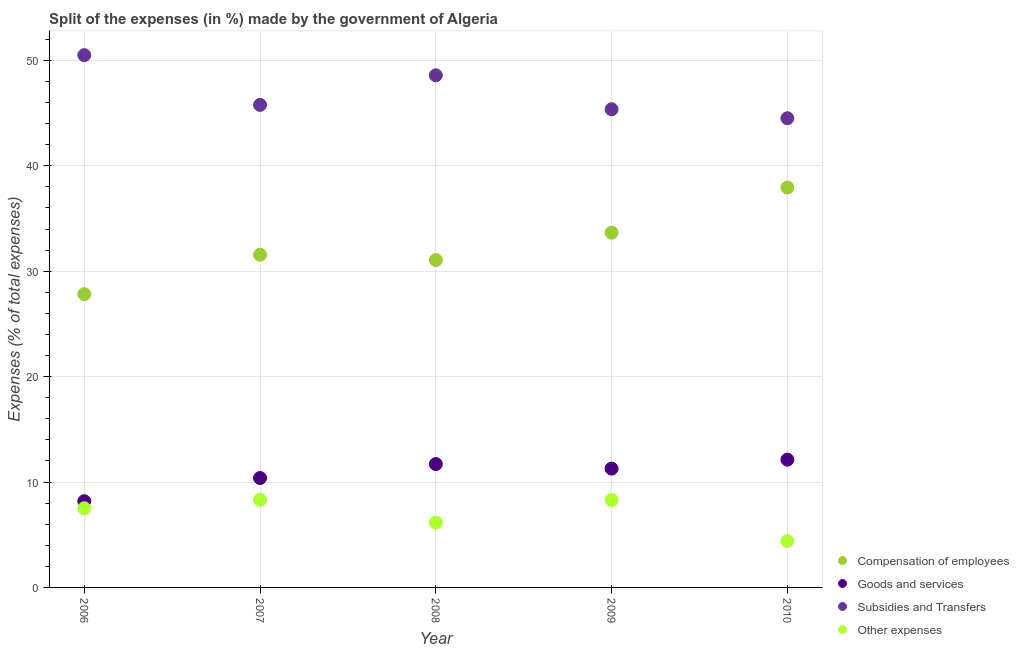How many different coloured dotlines are there?
Your answer should be very brief. 4. Is the number of dotlines equal to the number of legend labels?
Your answer should be compact. Yes. What is the percentage of amount spent on compensation of employees in 2010?
Your response must be concise. 37.94. Across all years, what is the maximum percentage of amount spent on goods and services?
Provide a succinct answer. 12.12. Across all years, what is the minimum percentage of amount spent on compensation of employees?
Offer a very short reply. 27.83. What is the total percentage of amount spent on subsidies in the graph?
Keep it short and to the point. 234.76. What is the difference between the percentage of amount spent on goods and services in 2007 and that in 2009?
Make the answer very short. -0.89. What is the difference between the percentage of amount spent on other expenses in 2007 and the percentage of amount spent on subsidies in 2010?
Provide a succinct answer. -36.2. What is the average percentage of amount spent on compensation of employees per year?
Your answer should be very brief. 32.41. In the year 2006, what is the difference between the percentage of amount spent on other expenses and percentage of amount spent on compensation of employees?
Your answer should be very brief. -20.32. In how many years, is the percentage of amount spent on other expenses greater than 16 %?
Give a very brief answer. 0. What is the ratio of the percentage of amount spent on subsidies in 2007 to that in 2008?
Offer a terse response. 0.94. Is the percentage of amount spent on compensation of employees in 2006 less than that in 2007?
Your answer should be very brief. Yes. Is the difference between the percentage of amount spent on other expenses in 2008 and 2009 greater than the difference between the percentage of amount spent on subsidies in 2008 and 2009?
Provide a succinct answer. No. What is the difference between the highest and the second highest percentage of amount spent on subsidies?
Ensure brevity in your answer.  1.91. What is the difference between the highest and the lowest percentage of amount spent on other expenses?
Offer a very short reply. 3.92. In how many years, is the percentage of amount spent on goods and services greater than the average percentage of amount spent on goods and services taken over all years?
Make the answer very short. 3. Is it the case that in every year, the sum of the percentage of amount spent on compensation of employees and percentage of amount spent on goods and services is greater than the percentage of amount spent on subsidies?
Offer a terse response. No. Does the percentage of amount spent on subsidies monotonically increase over the years?
Make the answer very short. No. Is the percentage of amount spent on other expenses strictly greater than the percentage of amount spent on compensation of employees over the years?
Provide a succinct answer. No. Is the percentage of amount spent on subsidies strictly less than the percentage of amount spent on goods and services over the years?
Provide a succinct answer. No. How many dotlines are there?
Make the answer very short. 4. How many years are there in the graph?
Your answer should be very brief. 5. What is the difference between two consecutive major ticks on the Y-axis?
Provide a succinct answer. 10. Are the values on the major ticks of Y-axis written in scientific E-notation?
Ensure brevity in your answer.  No. Does the graph contain any zero values?
Provide a succinct answer. No. Where does the legend appear in the graph?
Offer a terse response. Bottom right. How many legend labels are there?
Your answer should be very brief. 4. What is the title of the graph?
Give a very brief answer. Split of the expenses (in %) made by the government of Algeria. What is the label or title of the Y-axis?
Your answer should be compact. Expenses (% of total expenses). What is the Expenses (% of total expenses) of Compensation of employees in 2006?
Offer a terse response. 27.83. What is the Expenses (% of total expenses) of Goods and services in 2006?
Offer a terse response. 8.18. What is the Expenses (% of total expenses) of Subsidies and Transfers in 2006?
Give a very brief answer. 50.5. What is the Expenses (% of total expenses) of Other expenses in 2006?
Your answer should be very brief. 7.51. What is the Expenses (% of total expenses) of Compensation of employees in 2007?
Provide a succinct answer. 31.57. What is the Expenses (% of total expenses) in Goods and services in 2007?
Your answer should be compact. 10.38. What is the Expenses (% of total expenses) in Subsidies and Transfers in 2007?
Ensure brevity in your answer.  45.78. What is the Expenses (% of total expenses) of Other expenses in 2007?
Offer a terse response. 8.32. What is the Expenses (% of total expenses) of Compensation of employees in 2008?
Make the answer very short. 31.07. What is the Expenses (% of total expenses) in Goods and services in 2008?
Offer a very short reply. 11.7. What is the Expenses (% of total expenses) in Subsidies and Transfers in 2008?
Your response must be concise. 48.59. What is the Expenses (% of total expenses) in Other expenses in 2008?
Make the answer very short. 6.15. What is the Expenses (% of total expenses) in Compensation of employees in 2009?
Give a very brief answer. 33.66. What is the Expenses (% of total expenses) of Goods and services in 2009?
Provide a short and direct response. 11.27. What is the Expenses (% of total expenses) in Subsidies and Transfers in 2009?
Your answer should be very brief. 45.37. What is the Expenses (% of total expenses) of Other expenses in 2009?
Offer a very short reply. 8.3. What is the Expenses (% of total expenses) of Compensation of employees in 2010?
Your answer should be compact. 37.94. What is the Expenses (% of total expenses) in Goods and services in 2010?
Your answer should be compact. 12.12. What is the Expenses (% of total expenses) of Subsidies and Transfers in 2010?
Offer a terse response. 44.52. What is the Expenses (% of total expenses) of Other expenses in 2010?
Give a very brief answer. 4.39. Across all years, what is the maximum Expenses (% of total expenses) in Compensation of employees?
Your answer should be very brief. 37.94. Across all years, what is the maximum Expenses (% of total expenses) in Goods and services?
Your answer should be very brief. 12.12. Across all years, what is the maximum Expenses (% of total expenses) in Subsidies and Transfers?
Provide a short and direct response. 50.5. Across all years, what is the maximum Expenses (% of total expenses) of Other expenses?
Provide a succinct answer. 8.32. Across all years, what is the minimum Expenses (% of total expenses) in Compensation of employees?
Give a very brief answer. 27.83. Across all years, what is the minimum Expenses (% of total expenses) in Goods and services?
Make the answer very short. 8.18. Across all years, what is the minimum Expenses (% of total expenses) of Subsidies and Transfers?
Your answer should be compact. 44.52. Across all years, what is the minimum Expenses (% of total expenses) of Other expenses?
Keep it short and to the point. 4.39. What is the total Expenses (% of total expenses) in Compensation of employees in the graph?
Make the answer very short. 162.06. What is the total Expenses (% of total expenses) of Goods and services in the graph?
Your answer should be very brief. 53.66. What is the total Expenses (% of total expenses) of Subsidies and Transfers in the graph?
Offer a terse response. 234.76. What is the total Expenses (% of total expenses) in Other expenses in the graph?
Offer a terse response. 34.67. What is the difference between the Expenses (% of total expenses) in Compensation of employees in 2006 and that in 2007?
Your answer should be very brief. -3.74. What is the difference between the Expenses (% of total expenses) of Goods and services in 2006 and that in 2007?
Your response must be concise. -2.2. What is the difference between the Expenses (% of total expenses) of Subsidies and Transfers in 2006 and that in 2007?
Ensure brevity in your answer.  4.72. What is the difference between the Expenses (% of total expenses) in Other expenses in 2006 and that in 2007?
Ensure brevity in your answer.  -0.8. What is the difference between the Expenses (% of total expenses) in Compensation of employees in 2006 and that in 2008?
Make the answer very short. -3.24. What is the difference between the Expenses (% of total expenses) in Goods and services in 2006 and that in 2008?
Make the answer very short. -3.52. What is the difference between the Expenses (% of total expenses) of Subsidies and Transfers in 2006 and that in 2008?
Provide a succinct answer. 1.91. What is the difference between the Expenses (% of total expenses) in Other expenses in 2006 and that in 2008?
Give a very brief answer. 1.36. What is the difference between the Expenses (% of total expenses) of Compensation of employees in 2006 and that in 2009?
Provide a short and direct response. -5.83. What is the difference between the Expenses (% of total expenses) of Goods and services in 2006 and that in 2009?
Offer a very short reply. -3.09. What is the difference between the Expenses (% of total expenses) of Subsidies and Transfers in 2006 and that in 2009?
Offer a very short reply. 5.14. What is the difference between the Expenses (% of total expenses) of Other expenses in 2006 and that in 2009?
Your answer should be very brief. -0.79. What is the difference between the Expenses (% of total expenses) of Compensation of employees in 2006 and that in 2010?
Your response must be concise. -10.11. What is the difference between the Expenses (% of total expenses) of Goods and services in 2006 and that in 2010?
Your response must be concise. -3.94. What is the difference between the Expenses (% of total expenses) of Subsidies and Transfers in 2006 and that in 2010?
Provide a succinct answer. 5.99. What is the difference between the Expenses (% of total expenses) of Other expenses in 2006 and that in 2010?
Give a very brief answer. 3.12. What is the difference between the Expenses (% of total expenses) of Compensation of employees in 2007 and that in 2008?
Ensure brevity in your answer.  0.5. What is the difference between the Expenses (% of total expenses) in Goods and services in 2007 and that in 2008?
Ensure brevity in your answer.  -1.32. What is the difference between the Expenses (% of total expenses) in Subsidies and Transfers in 2007 and that in 2008?
Your response must be concise. -2.81. What is the difference between the Expenses (% of total expenses) of Other expenses in 2007 and that in 2008?
Your answer should be compact. 2.17. What is the difference between the Expenses (% of total expenses) of Compensation of employees in 2007 and that in 2009?
Ensure brevity in your answer.  -2.09. What is the difference between the Expenses (% of total expenses) of Goods and services in 2007 and that in 2009?
Ensure brevity in your answer.  -0.89. What is the difference between the Expenses (% of total expenses) of Subsidies and Transfers in 2007 and that in 2009?
Offer a very short reply. 0.42. What is the difference between the Expenses (% of total expenses) of Other expenses in 2007 and that in 2009?
Provide a short and direct response. 0.02. What is the difference between the Expenses (% of total expenses) of Compensation of employees in 2007 and that in 2010?
Make the answer very short. -6.37. What is the difference between the Expenses (% of total expenses) in Goods and services in 2007 and that in 2010?
Your response must be concise. -1.74. What is the difference between the Expenses (% of total expenses) of Subsidies and Transfers in 2007 and that in 2010?
Offer a very short reply. 1.27. What is the difference between the Expenses (% of total expenses) of Other expenses in 2007 and that in 2010?
Offer a very short reply. 3.92. What is the difference between the Expenses (% of total expenses) of Compensation of employees in 2008 and that in 2009?
Provide a short and direct response. -2.59. What is the difference between the Expenses (% of total expenses) in Goods and services in 2008 and that in 2009?
Your answer should be very brief. 0.43. What is the difference between the Expenses (% of total expenses) of Subsidies and Transfers in 2008 and that in 2009?
Keep it short and to the point. 3.22. What is the difference between the Expenses (% of total expenses) in Other expenses in 2008 and that in 2009?
Give a very brief answer. -2.15. What is the difference between the Expenses (% of total expenses) in Compensation of employees in 2008 and that in 2010?
Your answer should be very brief. -6.87. What is the difference between the Expenses (% of total expenses) in Goods and services in 2008 and that in 2010?
Offer a very short reply. -0.42. What is the difference between the Expenses (% of total expenses) in Subsidies and Transfers in 2008 and that in 2010?
Provide a succinct answer. 4.07. What is the difference between the Expenses (% of total expenses) of Other expenses in 2008 and that in 2010?
Make the answer very short. 1.75. What is the difference between the Expenses (% of total expenses) of Compensation of employees in 2009 and that in 2010?
Your answer should be very brief. -4.28. What is the difference between the Expenses (% of total expenses) of Goods and services in 2009 and that in 2010?
Your response must be concise. -0.85. What is the difference between the Expenses (% of total expenses) of Subsidies and Transfers in 2009 and that in 2010?
Provide a short and direct response. 0.85. What is the difference between the Expenses (% of total expenses) of Other expenses in 2009 and that in 2010?
Give a very brief answer. 3.91. What is the difference between the Expenses (% of total expenses) of Compensation of employees in 2006 and the Expenses (% of total expenses) of Goods and services in 2007?
Offer a terse response. 17.45. What is the difference between the Expenses (% of total expenses) in Compensation of employees in 2006 and the Expenses (% of total expenses) in Subsidies and Transfers in 2007?
Offer a terse response. -17.95. What is the difference between the Expenses (% of total expenses) of Compensation of employees in 2006 and the Expenses (% of total expenses) of Other expenses in 2007?
Keep it short and to the point. 19.51. What is the difference between the Expenses (% of total expenses) in Goods and services in 2006 and the Expenses (% of total expenses) in Subsidies and Transfers in 2007?
Your response must be concise. -37.6. What is the difference between the Expenses (% of total expenses) in Goods and services in 2006 and the Expenses (% of total expenses) in Other expenses in 2007?
Your answer should be compact. -0.14. What is the difference between the Expenses (% of total expenses) in Subsidies and Transfers in 2006 and the Expenses (% of total expenses) in Other expenses in 2007?
Provide a succinct answer. 42.19. What is the difference between the Expenses (% of total expenses) of Compensation of employees in 2006 and the Expenses (% of total expenses) of Goods and services in 2008?
Give a very brief answer. 16.13. What is the difference between the Expenses (% of total expenses) in Compensation of employees in 2006 and the Expenses (% of total expenses) in Subsidies and Transfers in 2008?
Offer a very short reply. -20.76. What is the difference between the Expenses (% of total expenses) of Compensation of employees in 2006 and the Expenses (% of total expenses) of Other expenses in 2008?
Offer a very short reply. 21.68. What is the difference between the Expenses (% of total expenses) of Goods and services in 2006 and the Expenses (% of total expenses) of Subsidies and Transfers in 2008?
Ensure brevity in your answer.  -40.41. What is the difference between the Expenses (% of total expenses) of Goods and services in 2006 and the Expenses (% of total expenses) of Other expenses in 2008?
Offer a terse response. 2.03. What is the difference between the Expenses (% of total expenses) in Subsidies and Transfers in 2006 and the Expenses (% of total expenses) in Other expenses in 2008?
Your response must be concise. 44.36. What is the difference between the Expenses (% of total expenses) of Compensation of employees in 2006 and the Expenses (% of total expenses) of Goods and services in 2009?
Offer a very short reply. 16.56. What is the difference between the Expenses (% of total expenses) in Compensation of employees in 2006 and the Expenses (% of total expenses) in Subsidies and Transfers in 2009?
Provide a succinct answer. -17.54. What is the difference between the Expenses (% of total expenses) of Compensation of employees in 2006 and the Expenses (% of total expenses) of Other expenses in 2009?
Offer a very short reply. 19.53. What is the difference between the Expenses (% of total expenses) in Goods and services in 2006 and the Expenses (% of total expenses) in Subsidies and Transfers in 2009?
Give a very brief answer. -37.19. What is the difference between the Expenses (% of total expenses) of Goods and services in 2006 and the Expenses (% of total expenses) of Other expenses in 2009?
Keep it short and to the point. -0.12. What is the difference between the Expenses (% of total expenses) in Subsidies and Transfers in 2006 and the Expenses (% of total expenses) in Other expenses in 2009?
Give a very brief answer. 42.21. What is the difference between the Expenses (% of total expenses) of Compensation of employees in 2006 and the Expenses (% of total expenses) of Goods and services in 2010?
Give a very brief answer. 15.71. What is the difference between the Expenses (% of total expenses) in Compensation of employees in 2006 and the Expenses (% of total expenses) in Subsidies and Transfers in 2010?
Provide a succinct answer. -16.69. What is the difference between the Expenses (% of total expenses) of Compensation of employees in 2006 and the Expenses (% of total expenses) of Other expenses in 2010?
Provide a succinct answer. 23.44. What is the difference between the Expenses (% of total expenses) in Goods and services in 2006 and the Expenses (% of total expenses) in Subsidies and Transfers in 2010?
Offer a terse response. -36.34. What is the difference between the Expenses (% of total expenses) of Goods and services in 2006 and the Expenses (% of total expenses) of Other expenses in 2010?
Give a very brief answer. 3.79. What is the difference between the Expenses (% of total expenses) in Subsidies and Transfers in 2006 and the Expenses (% of total expenses) in Other expenses in 2010?
Ensure brevity in your answer.  46.11. What is the difference between the Expenses (% of total expenses) in Compensation of employees in 2007 and the Expenses (% of total expenses) in Goods and services in 2008?
Your answer should be compact. 19.86. What is the difference between the Expenses (% of total expenses) in Compensation of employees in 2007 and the Expenses (% of total expenses) in Subsidies and Transfers in 2008?
Make the answer very short. -17.02. What is the difference between the Expenses (% of total expenses) of Compensation of employees in 2007 and the Expenses (% of total expenses) of Other expenses in 2008?
Keep it short and to the point. 25.42. What is the difference between the Expenses (% of total expenses) of Goods and services in 2007 and the Expenses (% of total expenses) of Subsidies and Transfers in 2008?
Keep it short and to the point. -38.21. What is the difference between the Expenses (% of total expenses) of Goods and services in 2007 and the Expenses (% of total expenses) of Other expenses in 2008?
Your answer should be very brief. 4.23. What is the difference between the Expenses (% of total expenses) in Subsidies and Transfers in 2007 and the Expenses (% of total expenses) in Other expenses in 2008?
Your response must be concise. 39.64. What is the difference between the Expenses (% of total expenses) in Compensation of employees in 2007 and the Expenses (% of total expenses) in Goods and services in 2009?
Keep it short and to the point. 20.29. What is the difference between the Expenses (% of total expenses) in Compensation of employees in 2007 and the Expenses (% of total expenses) in Subsidies and Transfers in 2009?
Offer a very short reply. -13.8. What is the difference between the Expenses (% of total expenses) in Compensation of employees in 2007 and the Expenses (% of total expenses) in Other expenses in 2009?
Offer a terse response. 23.27. What is the difference between the Expenses (% of total expenses) in Goods and services in 2007 and the Expenses (% of total expenses) in Subsidies and Transfers in 2009?
Offer a very short reply. -34.99. What is the difference between the Expenses (% of total expenses) of Goods and services in 2007 and the Expenses (% of total expenses) of Other expenses in 2009?
Offer a very short reply. 2.08. What is the difference between the Expenses (% of total expenses) in Subsidies and Transfers in 2007 and the Expenses (% of total expenses) in Other expenses in 2009?
Offer a very short reply. 37.48. What is the difference between the Expenses (% of total expenses) in Compensation of employees in 2007 and the Expenses (% of total expenses) in Goods and services in 2010?
Give a very brief answer. 19.45. What is the difference between the Expenses (% of total expenses) of Compensation of employees in 2007 and the Expenses (% of total expenses) of Subsidies and Transfers in 2010?
Offer a very short reply. -12.95. What is the difference between the Expenses (% of total expenses) of Compensation of employees in 2007 and the Expenses (% of total expenses) of Other expenses in 2010?
Offer a terse response. 27.17. What is the difference between the Expenses (% of total expenses) of Goods and services in 2007 and the Expenses (% of total expenses) of Subsidies and Transfers in 2010?
Keep it short and to the point. -34.14. What is the difference between the Expenses (% of total expenses) of Goods and services in 2007 and the Expenses (% of total expenses) of Other expenses in 2010?
Keep it short and to the point. 5.99. What is the difference between the Expenses (% of total expenses) in Subsidies and Transfers in 2007 and the Expenses (% of total expenses) in Other expenses in 2010?
Your response must be concise. 41.39. What is the difference between the Expenses (% of total expenses) of Compensation of employees in 2008 and the Expenses (% of total expenses) of Goods and services in 2009?
Offer a very short reply. 19.79. What is the difference between the Expenses (% of total expenses) of Compensation of employees in 2008 and the Expenses (% of total expenses) of Subsidies and Transfers in 2009?
Your answer should be compact. -14.3. What is the difference between the Expenses (% of total expenses) of Compensation of employees in 2008 and the Expenses (% of total expenses) of Other expenses in 2009?
Keep it short and to the point. 22.77. What is the difference between the Expenses (% of total expenses) of Goods and services in 2008 and the Expenses (% of total expenses) of Subsidies and Transfers in 2009?
Give a very brief answer. -33.66. What is the difference between the Expenses (% of total expenses) of Goods and services in 2008 and the Expenses (% of total expenses) of Other expenses in 2009?
Make the answer very short. 3.41. What is the difference between the Expenses (% of total expenses) of Subsidies and Transfers in 2008 and the Expenses (% of total expenses) of Other expenses in 2009?
Provide a succinct answer. 40.29. What is the difference between the Expenses (% of total expenses) in Compensation of employees in 2008 and the Expenses (% of total expenses) in Goods and services in 2010?
Offer a terse response. 18.95. What is the difference between the Expenses (% of total expenses) of Compensation of employees in 2008 and the Expenses (% of total expenses) of Subsidies and Transfers in 2010?
Offer a terse response. -13.45. What is the difference between the Expenses (% of total expenses) in Compensation of employees in 2008 and the Expenses (% of total expenses) in Other expenses in 2010?
Your answer should be compact. 26.67. What is the difference between the Expenses (% of total expenses) in Goods and services in 2008 and the Expenses (% of total expenses) in Subsidies and Transfers in 2010?
Your answer should be compact. -32.81. What is the difference between the Expenses (% of total expenses) of Goods and services in 2008 and the Expenses (% of total expenses) of Other expenses in 2010?
Give a very brief answer. 7.31. What is the difference between the Expenses (% of total expenses) in Subsidies and Transfers in 2008 and the Expenses (% of total expenses) in Other expenses in 2010?
Offer a very short reply. 44.2. What is the difference between the Expenses (% of total expenses) in Compensation of employees in 2009 and the Expenses (% of total expenses) in Goods and services in 2010?
Offer a terse response. 21.53. What is the difference between the Expenses (% of total expenses) in Compensation of employees in 2009 and the Expenses (% of total expenses) in Subsidies and Transfers in 2010?
Offer a very short reply. -10.86. What is the difference between the Expenses (% of total expenses) in Compensation of employees in 2009 and the Expenses (% of total expenses) in Other expenses in 2010?
Your answer should be compact. 29.26. What is the difference between the Expenses (% of total expenses) of Goods and services in 2009 and the Expenses (% of total expenses) of Subsidies and Transfers in 2010?
Keep it short and to the point. -33.24. What is the difference between the Expenses (% of total expenses) of Goods and services in 2009 and the Expenses (% of total expenses) of Other expenses in 2010?
Your answer should be compact. 6.88. What is the difference between the Expenses (% of total expenses) of Subsidies and Transfers in 2009 and the Expenses (% of total expenses) of Other expenses in 2010?
Ensure brevity in your answer.  40.97. What is the average Expenses (% of total expenses) in Compensation of employees per year?
Your answer should be compact. 32.41. What is the average Expenses (% of total expenses) in Goods and services per year?
Offer a terse response. 10.73. What is the average Expenses (% of total expenses) in Subsidies and Transfers per year?
Offer a terse response. 46.95. What is the average Expenses (% of total expenses) in Other expenses per year?
Give a very brief answer. 6.93. In the year 2006, what is the difference between the Expenses (% of total expenses) of Compensation of employees and Expenses (% of total expenses) of Goods and services?
Your answer should be compact. 19.65. In the year 2006, what is the difference between the Expenses (% of total expenses) in Compensation of employees and Expenses (% of total expenses) in Subsidies and Transfers?
Your answer should be compact. -22.67. In the year 2006, what is the difference between the Expenses (% of total expenses) of Compensation of employees and Expenses (% of total expenses) of Other expenses?
Provide a succinct answer. 20.32. In the year 2006, what is the difference between the Expenses (% of total expenses) in Goods and services and Expenses (% of total expenses) in Subsidies and Transfers?
Ensure brevity in your answer.  -42.32. In the year 2006, what is the difference between the Expenses (% of total expenses) in Goods and services and Expenses (% of total expenses) in Other expenses?
Your answer should be compact. 0.67. In the year 2006, what is the difference between the Expenses (% of total expenses) of Subsidies and Transfers and Expenses (% of total expenses) of Other expenses?
Offer a terse response. 42.99. In the year 2007, what is the difference between the Expenses (% of total expenses) in Compensation of employees and Expenses (% of total expenses) in Goods and services?
Ensure brevity in your answer.  21.19. In the year 2007, what is the difference between the Expenses (% of total expenses) in Compensation of employees and Expenses (% of total expenses) in Subsidies and Transfers?
Provide a succinct answer. -14.22. In the year 2007, what is the difference between the Expenses (% of total expenses) in Compensation of employees and Expenses (% of total expenses) in Other expenses?
Make the answer very short. 23.25. In the year 2007, what is the difference between the Expenses (% of total expenses) in Goods and services and Expenses (% of total expenses) in Subsidies and Transfers?
Your answer should be compact. -35.4. In the year 2007, what is the difference between the Expenses (% of total expenses) in Goods and services and Expenses (% of total expenses) in Other expenses?
Your answer should be very brief. 2.06. In the year 2007, what is the difference between the Expenses (% of total expenses) of Subsidies and Transfers and Expenses (% of total expenses) of Other expenses?
Offer a terse response. 37.47. In the year 2008, what is the difference between the Expenses (% of total expenses) of Compensation of employees and Expenses (% of total expenses) of Goods and services?
Offer a very short reply. 19.36. In the year 2008, what is the difference between the Expenses (% of total expenses) of Compensation of employees and Expenses (% of total expenses) of Subsidies and Transfers?
Your response must be concise. -17.52. In the year 2008, what is the difference between the Expenses (% of total expenses) in Compensation of employees and Expenses (% of total expenses) in Other expenses?
Your answer should be compact. 24.92. In the year 2008, what is the difference between the Expenses (% of total expenses) of Goods and services and Expenses (% of total expenses) of Subsidies and Transfers?
Give a very brief answer. -36.89. In the year 2008, what is the difference between the Expenses (% of total expenses) of Goods and services and Expenses (% of total expenses) of Other expenses?
Offer a very short reply. 5.56. In the year 2008, what is the difference between the Expenses (% of total expenses) in Subsidies and Transfers and Expenses (% of total expenses) in Other expenses?
Provide a short and direct response. 42.44. In the year 2009, what is the difference between the Expenses (% of total expenses) of Compensation of employees and Expenses (% of total expenses) of Goods and services?
Your response must be concise. 22.38. In the year 2009, what is the difference between the Expenses (% of total expenses) of Compensation of employees and Expenses (% of total expenses) of Subsidies and Transfers?
Offer a terse response. -11.71. In the year 2009, what is the difference between the Expenses (% of total expenses) of Compensation of employees and Expenses (% of total expenses) of Other expenses?
Your response must be concise. 25.36. In the year 2009, what is the difference between the Expenses (% of total expenses) in Goods and services and Expenses (% of total expenses) in Subsidies and Transfers?
Your response must be concise. -34.09. In the year 2009, what is the difference between the Expenses (% of total expenses) of Goods and services and Expenses (% of total expenses) of Other expenses?
Offer a very short reply. 2.97. In the year 2009, what is the difference between the Expenses (% of total expenses) of Subsidies and Transfers and Expenses (% of total expenses) of Other expenses?
Ensure brevity in your answer.  37.07. In the year 2010, what is the difference between the Expenses (% of total expenses) of Compensation of employees and Expenses (% of total expenses) of Goods and services?
Your answer should be very brief. 25.82. In the year 2010, what is the difference between the Expenses (% of total expenses) in Compensation of employees and Expenses (% of total expenses) in Subsidies and Transfers?
Make the answer very short. -6.58. In the year 2010, what is the difference between the Expenses (% of total expenses) of Compensation of employees and Expenses (% of total expenses) of Other expenses?
Provide a succinct answer. 33.55. In the year 2010, what is the difference between the Expenses (% of total expenses) of Goods and services and Expenses (% of total expenses) of Subsidies and Transfers?
Your answer should be very brief. -32.4. In the year 2010, what is the difference between the Expenses (% of total expenses) of Goods and services and Expenses (% of total expenses) of Other expenses?
Your answer should be compact. 7.73. In the year 2010, what is the difference between the Expenses (% of total expenses) of Subsidies and Transfers and Expenses (% of total expenses) of Other expenses?
Provide a succinct answer. 40.12. What is the ratio of the Expenses (% of total expenses) of Compensation of employees in 2006 to that in 2007?
Provide a short and direct response. 0.88. What is the ratio of the Expenses (% of total expenses) in Goods and services in 2006 to that in 2007?
Provide a short and direct response. 0.79. What is the ratio of the Expenses (% of total expenses) of Subsidies and Transfers in 2006 to that in 2007?
Give a very brief answer. 1.1. What is the ratio of the Expenses (% of total expenses) in Other expenses in 2006 to that in 2007?
Offer a very short reply. 0.9. What is the ratio of the Expenses (% of total expenses) of Compensation of employees in 2006 to that in 2008?
Offer a terse response. 0.9. What is the ratio of the Expenses (% of total expenses) in Goods and services in 2006 to that in 2008?
Give a very brief answer. 0.7. What is the ratio of the Expenses (% of total expenses) in Subsidies and Transfers in 2006 to that in 2008?
Your response must be concise. 1.04. What is the ratio of the Expenses (% of total expenses) of Other expenses in 2006 to that in 2008?
Your answer should be very brief. 1.22. What is the ratio of the Expenses (% of total expenses) of Compensation of employees in 2006 to that in 2009?
Make the answer very short. 0.83. What is the ratio of the Expenses (% of total expenses) in Goods and services in 2006 to that in 2009?
Your response must be concise. 0.73. What is the ratio of the Expenses (% of total expenses) of Subsidies and Transfers in 2006 to that in 2009?
Make the answer very short. 1.11. What is the ratio of the Expenses (% of total expenses) of Other expenses in 2006 to that in 2009?
Your answer should be very brief. 0.91. What is the ratio of the Expenses (% of total expenses) in Compensation of employees in 2006 to that in 2010?
Provide a succinct answer. 0.73. What is the ratio of the Expenses (% of total expenses) in Goods and services in 2006 to that in 2010?
Offer a very short reply. 0.67. What is the ratio of the Expenses (% of total expenses) in Subsidies and Transfers in 2006 to that in 2010?
Your answer should be compact. 1.13. What is the ratio of the Expenses (% of total expenses) of Other expenses in 2006 to that in 2010?
Your response must be concise. 1.71. What is the ratio of the Expenses (% of total expenses) of Compensation of employees in 2007 to that in 2008?
Your response must be concise. 1.02. What is the ratio of the Expenses (% of total expenses) in Goods and services in 2007 to that in 2008?
Provide a short and direct response. 0.89. What is the ratio of the Expenses (% of total expenses) of Subsidies and Transfers in 2007 to that in 2008?
Ensure brevity in your answer.  0.94. What is the ratio of the Expenses (% of total expenses) in Other expenses in 2007 to that in 2008?
Offer a very short reply. 1.35. What is the ratio of the Expenses (% of total expenses) in Compensation of employees in 2007 to that in 2009?
Provide a short and direct response. 0.94. What is the ratio of the Expenses (% of total expenses) of Goods and services in 2007 to that in 2009?
Your response must be concise. 0.92. What is the ratio of the Expenses (% of total expenses) of Subsidies and Transfers in 2007 to that in 2009?
Make the answer very short. 1.01. What is the ratio of the Expenses (% of total expenses) of Other expenses in 2007 to that in 2009?
Provide a short and direct response. 1. What is the ratio of the Expenses (% of total expenses) of Compensation of employees in 2007 to that in 2010?
Give a very brief answer. 0.83. What is the ratio of the Expenses (% of total expenses) in Goods and services in 2007 to that in 2010?
Give a very brief answer. 0.86. What is the ratio of the Expenses (% of total expenses) in Subsidies and Transfers in 2007 to that in 2010?
Your answer should be very brief. 1.03. What is the ratio of the Expenses (% of total expenses) in Other expenses in 2007 to that in 2010?
Give a very brief answer. 1.89. What is the ratio of the Expenses (% of total expenses) of Goods and services in 2008 to that in 2009?
Your answer should be compact. 1.04. What is the ratio of the Expenses (% of total expenses) in Subsidies and Transfers in 2008 to that in 2009?
Offer a very short reply. 1.07. What is the ratio of the Expenses (% of total expenses) in Other expenses in 2008 to that in 2009?
Make the answer very short. 0.74. What is the ratio of the Expenses (% of total expenses) in Compensation of employees in 2008 to that in 2010?
Keep it short and to the point. 0.82. What is the ratio of the Expenses (% of total expenses) of Goods and services in 2008 to that in 2010?
Your answer should be very brief. 0.97. What is the ratio of the Expenses (% of total expenses) in Subsidies and Transfers in 2008 to that in 2010?
Ensure brevity in your answer.  1.09. What is the ratio of the Expenses (% of total expenses) of Other expenses in 2008 to that in 2010?
Keep it short and to the point. 1.4. What is the ratio of the Expenses (% of total expenses) of Compensation of employees in 2009 to that in 2010?
Ensure brevity in your answer.  0.89. What is the ratio of the Expenses (% of total expenses) in Goods and services in 2009 to that in 2010?
Provide a succinct answer. 0.93. What is the ratio of the Expenses (% of total expenses) of Subsidies and Transfers in 2009 to that in 2010?
Ensure brevity in your answer.  1.02. What is the ratio of the Expenses (% of total expenses) in Other expenses in 2009 to that in 2010?
Your response must be concise. 1.89. What is the difference between the highest and the second highest Expenses (% of total expenses) of Compensation of employees?
Provide a short and direct response. 4.28. What is the difference between the highest and the second highest Expenses (% of total expenses) of Goods and services?
Keep it short and to the point. 0.42. What is the difference between the highest and the second highest Expenses (% of total expenses) of Subsidies and Transfers?
Ensure brevity in your answer.  1.91. What is the difference between the highest and the second highest Expenses (% of total expenses) of Other expenses?
Provide a succinct answer. 0.02. What is the difference between the highest and the lowest Expenses (% of total expenses) in Compensation of employees?
Make the answer very short. 10.11. What is the difference between the highest and the lowest Expenses (% of total expenses) in Goods and services?
Your answer should be very brief. 3.94. What is the difference between the highest and the lowest Expenses (% of total expenses) of Subsidies and Transfers?
Your answer should be compact. 5.99. What is the difference between the highest and the lowest Expenses (% of total expenses) of Other expenses?
Provide a short and direct response. 3.92. 